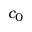Convert formula to latex. <formula><loc_0><loc_0><loc_500><loc_500>c _ { 0 }</formula> 